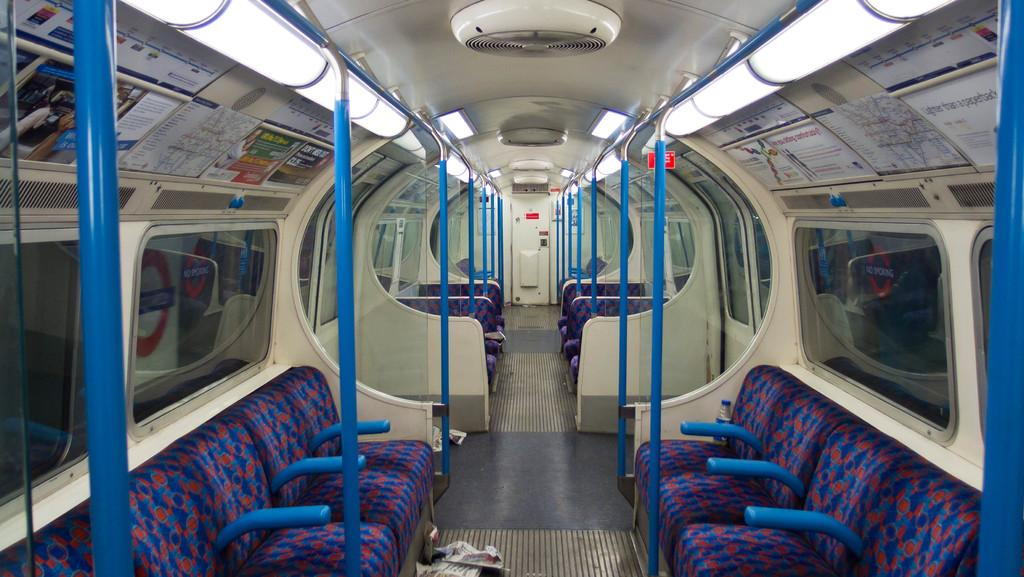What part of a train is shown in the image? The image shows the inner part of a train. What type of seating is available in the train? There are chairs in the image. What color are the poles in the train? The poles in the image are blue. What feature allows passengers to see the outside while inside the train? There are glass windows on both the left and right sides of the image. What provides illumination inside the train? Lights are visible in the image. How many brothers are sitting together in the image? There is no information about any brothers in the image, as it only shows the interior of a train with chairs, blue poles, glass windows, and lights. 